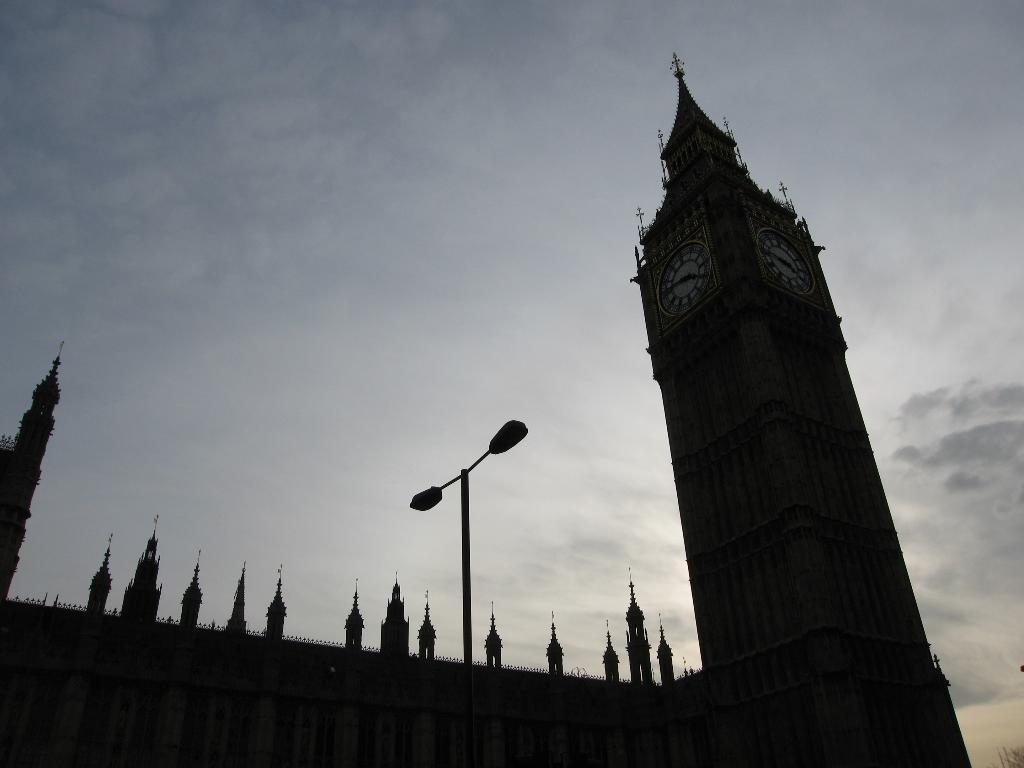What is located in the center of the image? There is a street light and a building in the center of the image. What can be seen in the background of the image? The sky is visible in the background of the image, and there are clouds present. Where is the faucet located in the image? There is no faucet present in the image. What type of crime is being committed in the image? There is no indication of any crime in the image. 